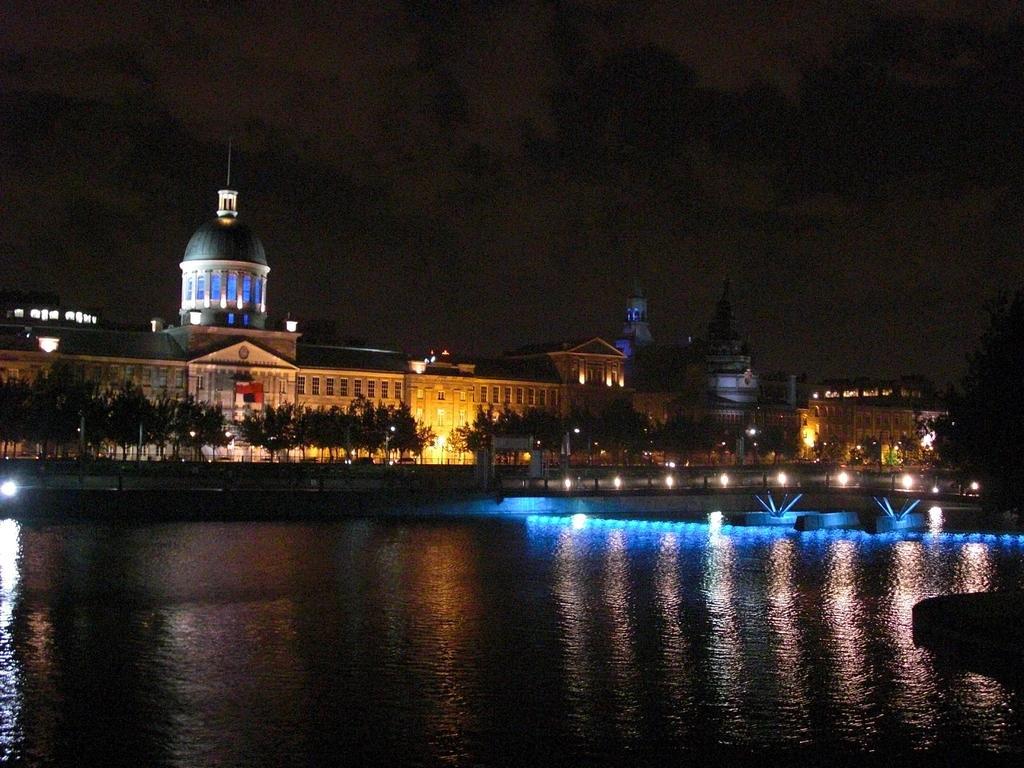Could you give a brief overview of what you see in this image? In this picture we can see water, trees, buildings with windows and in the background we can see the sky. 